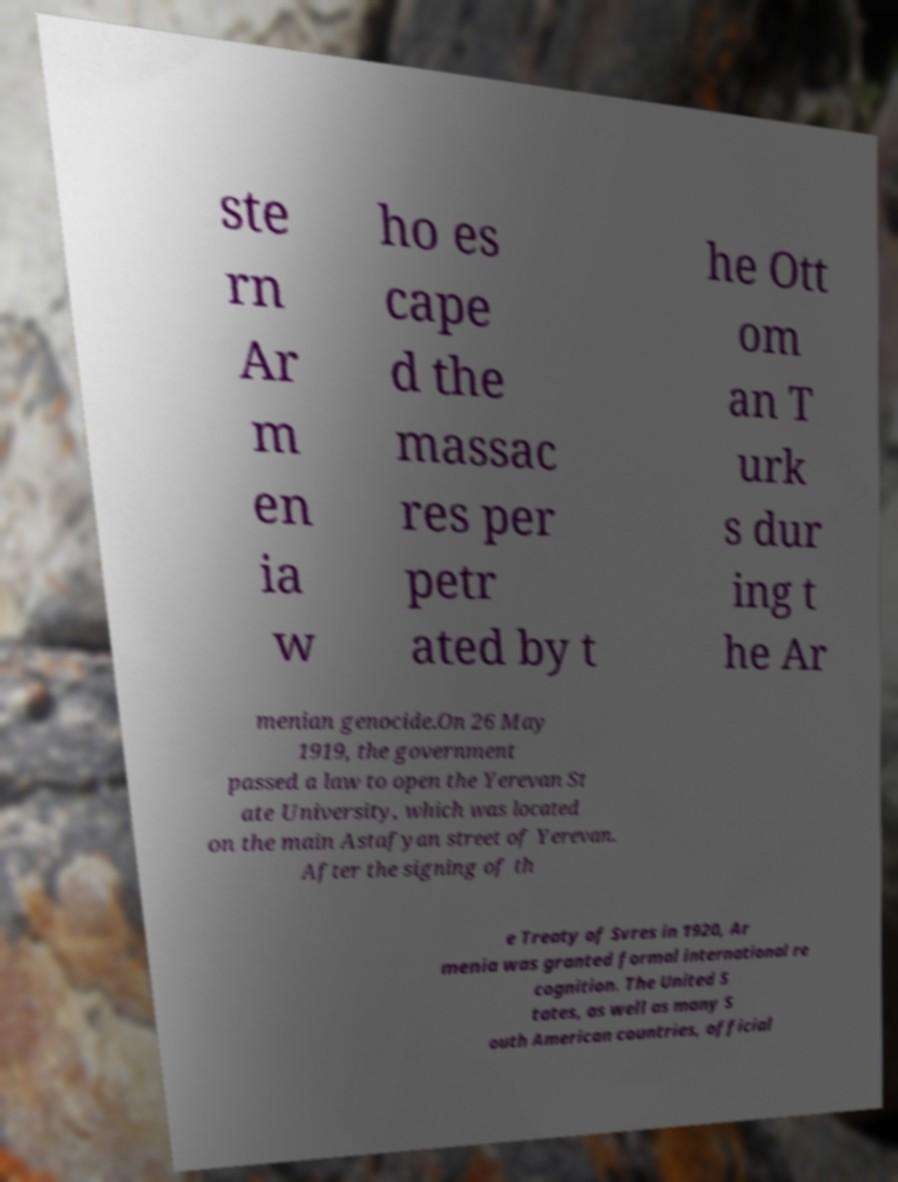Could you extract and type out the text from this image? ste rn Ar m en ia w ho es cape d the massac res per petr ated by t he Ott om an T urk s dur ing t he Ar menian genocide.On 26 May 1919, the government passed a law to open the Yerevan St ate University, which was located on the main Astafyan street of Yerevan. After the signing of th e Treaty of Svres in 1920, Ar menia was granted formal international re cognition. The United S tates, as well as many S outh American countries, official 